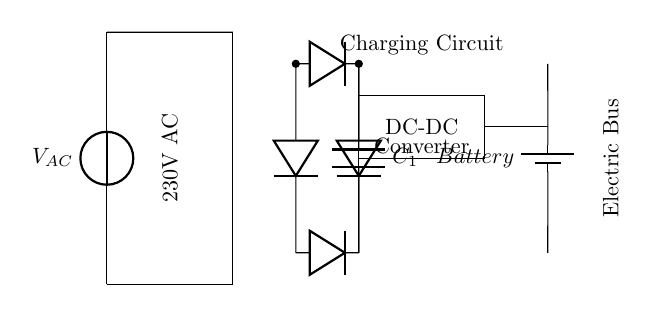What components are present in the charging circuit? The diagram shows a voltage source, transformer, diodes, a capacitor, a DC-DC converter, and a battery. These elements are essential for transforming AC power to DC power suitable for charging the battery.
Answer: Voltage source, transformer, diodes, capacitor, DC-DC converter, battery What is the voltage input for the circuit? The circuit specifies an AC voltage source labeled as 230V. This voltage is used to energize the transformer, which adapts the voltage levels for the rest of the charging circuit.
Answer: 230V What is the purpose of the rectifier in this circuit? The rectifier (consisting of diodes) converts AC voltage from the transformer into DC voltage. This process is necessary for properly charging the DC battery, as batteries require a direct current (DC) to charge effectively.
Answer: To convert AC to DC How does the smoothing capacitor affect the charging process? The smoothing capacitor, labeled as C1, smooths out the fluctuations in the DC voltage produced by the rectifier. It helps to provide a more stable voltage level to the battery, which is crucial for effective charging without damaging the battery.
Answer: Stabilizes voltage What is the function of the DC-DC converter in this circuit? The DC-DC converter adjusts the voltage to the required level for charging the battery efficiently. Depending on the battery's specifications, the converter can step up or step down the voltage to ensure proper charging conditions.
Answer: Adjusts charging voltage What is the significance of the battery in this circuit? The battery is the energy storage component of this charging circuit. It stores the electrical energy supplied through the charging circuit for later use, specifically to power the electric bus when needed.
Answer: Energy storage component 